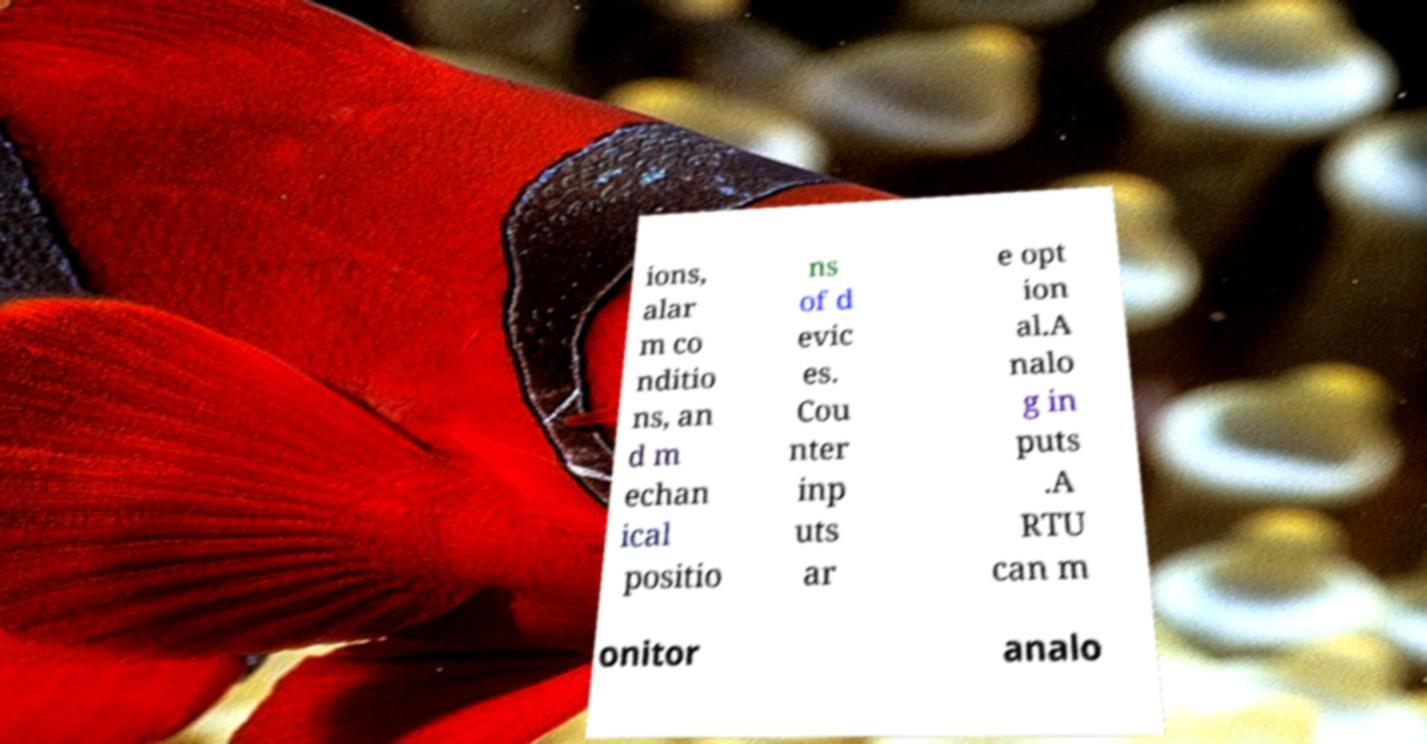Could you extract and type out the text from this image? ions, alar m co nditio ns, an d m echan ical positio ns of d evic es. Cou nter inp uts ar e opt ion al.A nalo g in puts .A RTU can m onitor analo 